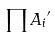<formula> <loc_0><loc_0><loc_500><loc_500>\prod { A _ { i } } ^ { \prime }</formula> 